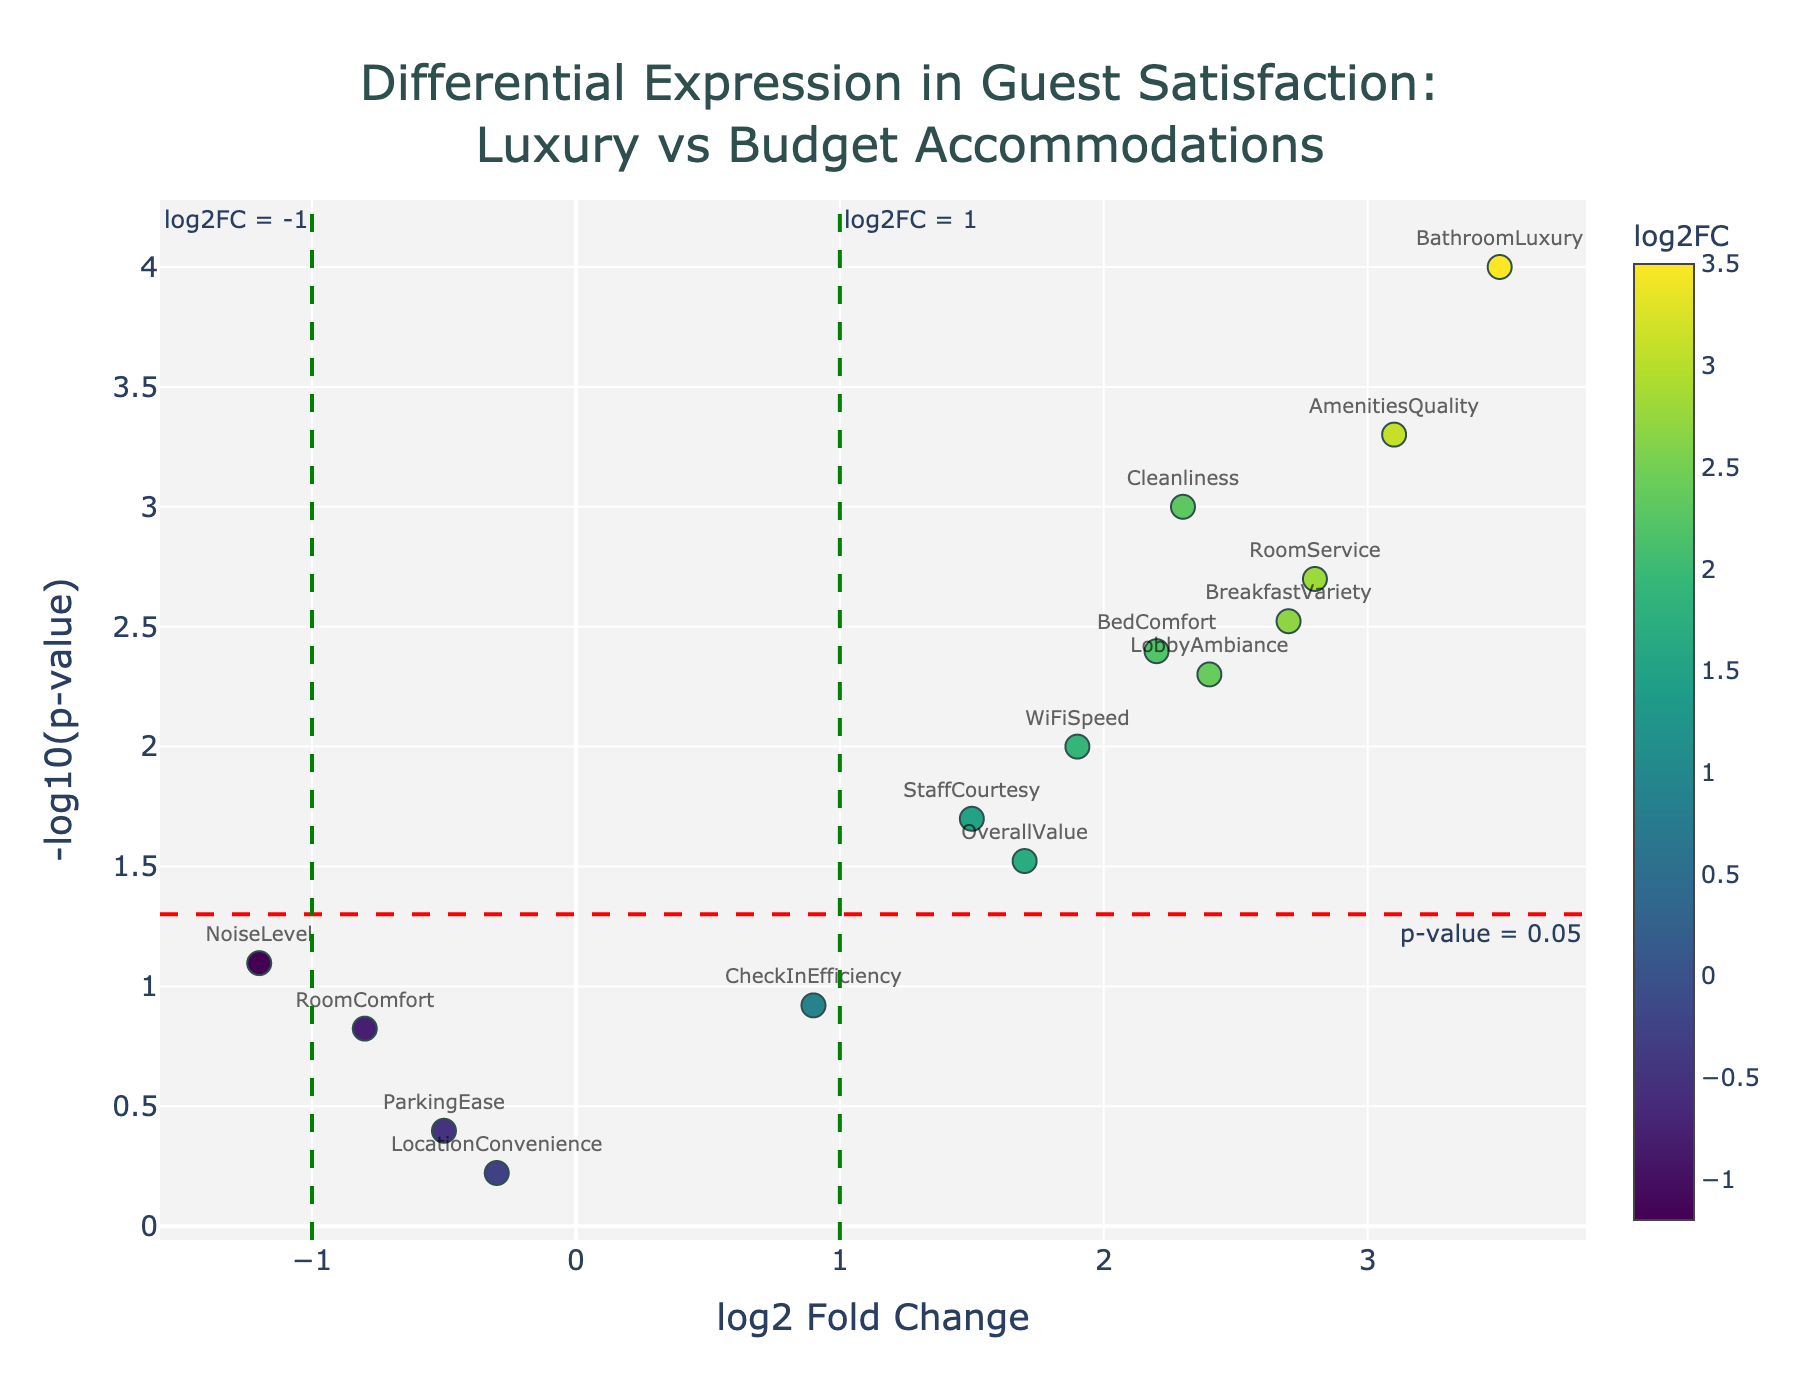How many data points have a p-value less than 0.05? Observe the y-axis (-log10(p-value)). Data points above the horizontal red dotted line at y = 1.3 represent p-values less than 0.05. Count the points above this line. These points are: Cleanliness, StaffCourtesy, AmenitiesQuality, BreakfastVariety, WiFiSpeed, BedComfort, BathroomLuxury, RoomService, LobbyAmbiance, and OverallValue.
Answer: 10 Which feature has the highest log2 fold change? Look at the x-axis (log2 Fold Change) and identify the data point that is farthest to the right. The furthest point to the right is BathroomLuxury with a log2 Fold Change of 3.5.
Answer: BathroomLuxury Which feature has the lowest log2 fold change? Look at the x-axis (log2 Fold Change) and identify the data point that is farthest to the left. The furthest point to the left is NoiseLevel with a log2 Fold Change of -1.2.
Answer: NoiseLevel For which feature is the p-value the highest? The highest p-value is the smallest -log10(p-value), so look for the data point closest to the x-axis. The closest point to the x-axis is LocationConvenience.
Answer: LocationConvenience How many features have a log2 fold change greater than 2? Count the data points that are to the right of the vertical green dashed line at x = 2. These points are Cleanliness, AmenitiesQuality, BathroomLuxury, BreakfastVariety, RoomService, BedComfort, and LobbyAmbiance.
Answer: 7 What is the feature with the most statistically significant increase in satisfaction? The most statistically significant increase would be the data point furthest from the x-axis with a high log2 fold change. BathroomLuxury has the highest -log10(p-value) and a log2 fold change of 3.5.
Answer: BathroomLuxury Which features are below both the threshold lines for log2 fold change and p-value? Identify data points that lie to the left of the green vertical line at x = 1 and below the horizontal red line at y = 1.3. These points include RoomComfort, LocationConvenience, NoiseLevel, CheckInEfficiency, and ParkingEase.
Answer: 5 For amenities, what can we conclude about the differential expression in customer satisfaction between luxury and budget accommodations? Evaluate the data points related to amenities, such as Cleanliness, AmenitiesQuality, BreakfastVariety, WiFiSpeed, BedComfort, BathroomLuxury, and RoomService. Most of these points have a positive log2 fold change and a p-value below 0.05, indicating higher satisfaction in luxury accommodations.
Answer: Luxury accommodations have higher satisfaction 